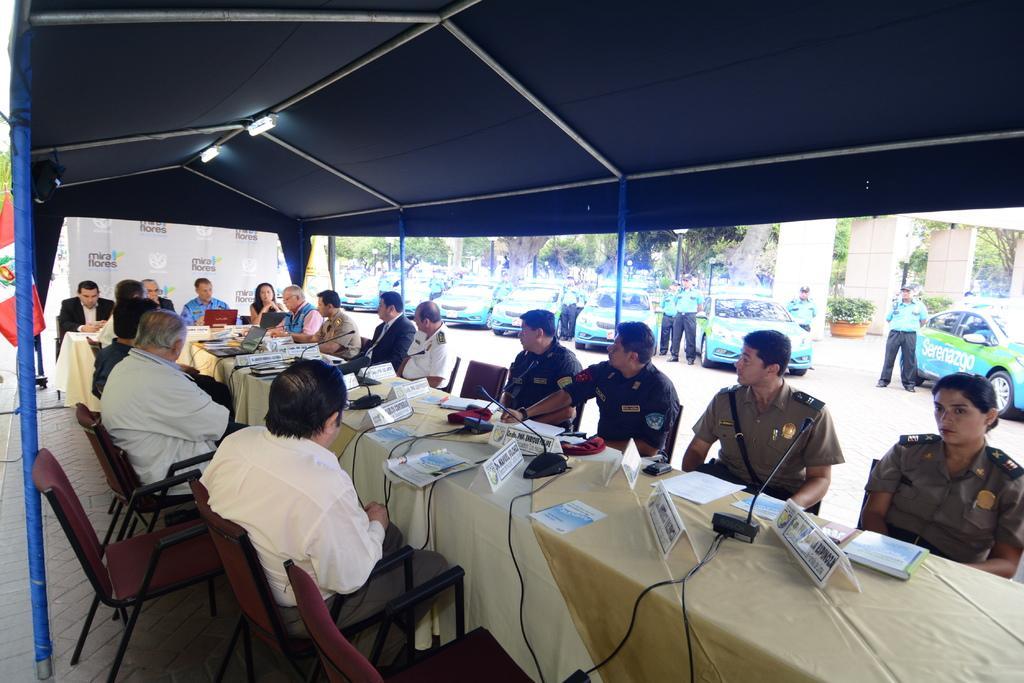Describe this image in one or two sentences. In this image there are group of people sitting on the chair. On the table there is a book,paper,mic and a laptop. At the back side there are cars and trees. 